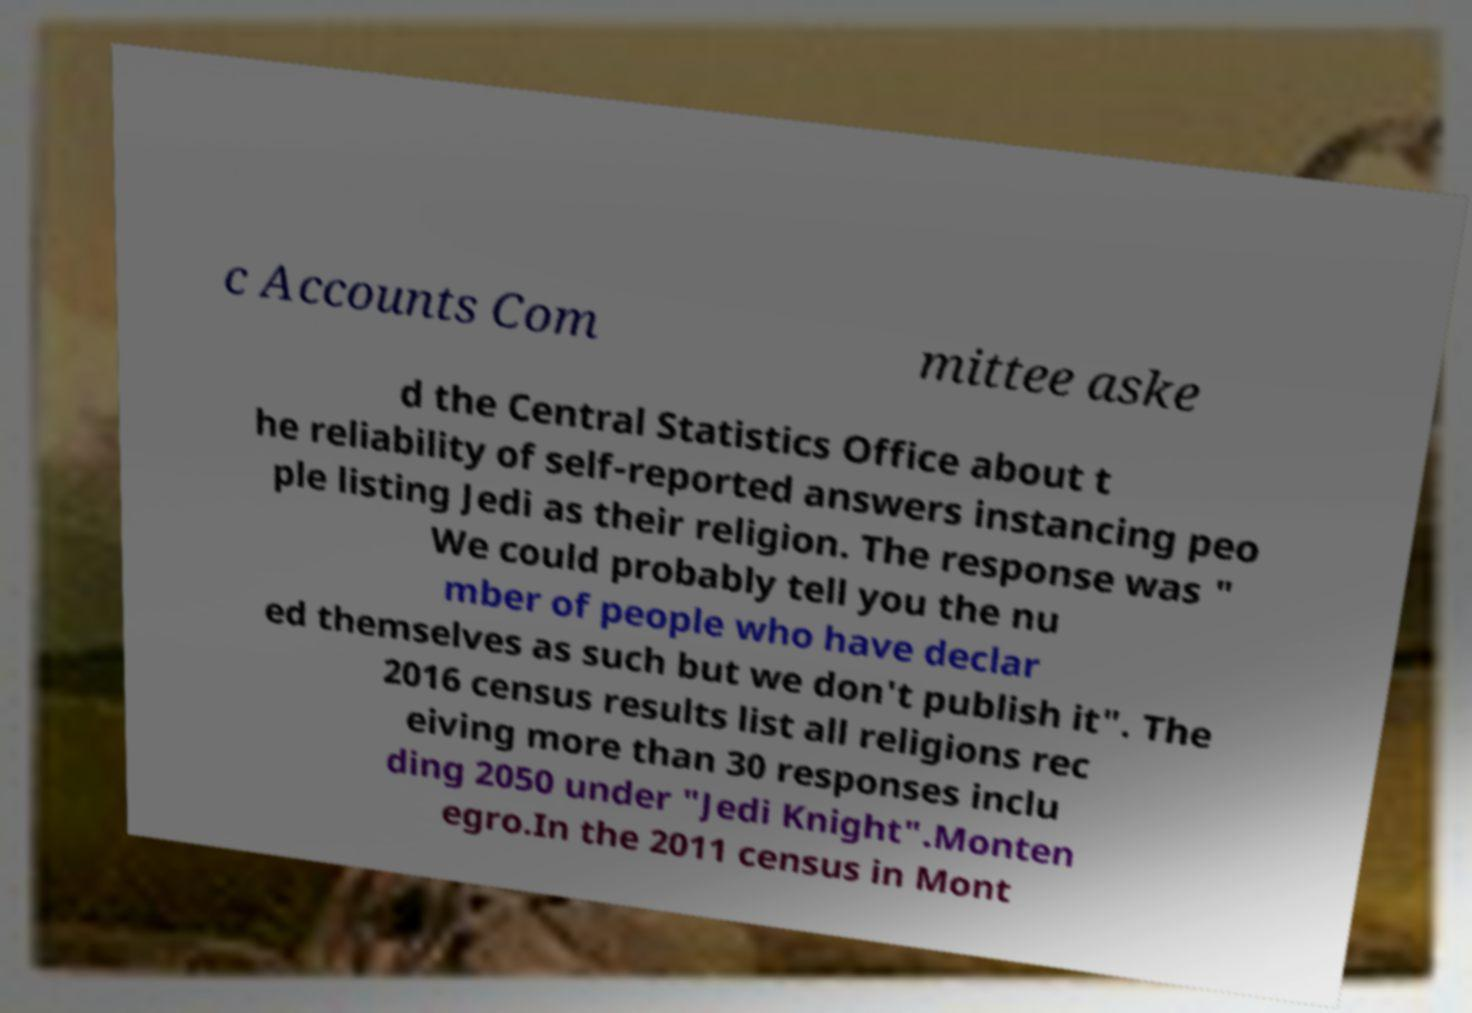Please read and relay the text visible in this image. What does it say? c Accounts Com mittee aske d the Central Statistics Office about t he reliability of self-reported answers instancing peo ple listing Jedi as their religion. The response was " We could probably tell you the nu mber of people who have declar ed themselves as such but we don't publish it". The 2016 census results list all religions rec eiving more than 30 responses inclu ding 2050 under "Jedi Knight".Monten egro.In the 2011 census in Mont 